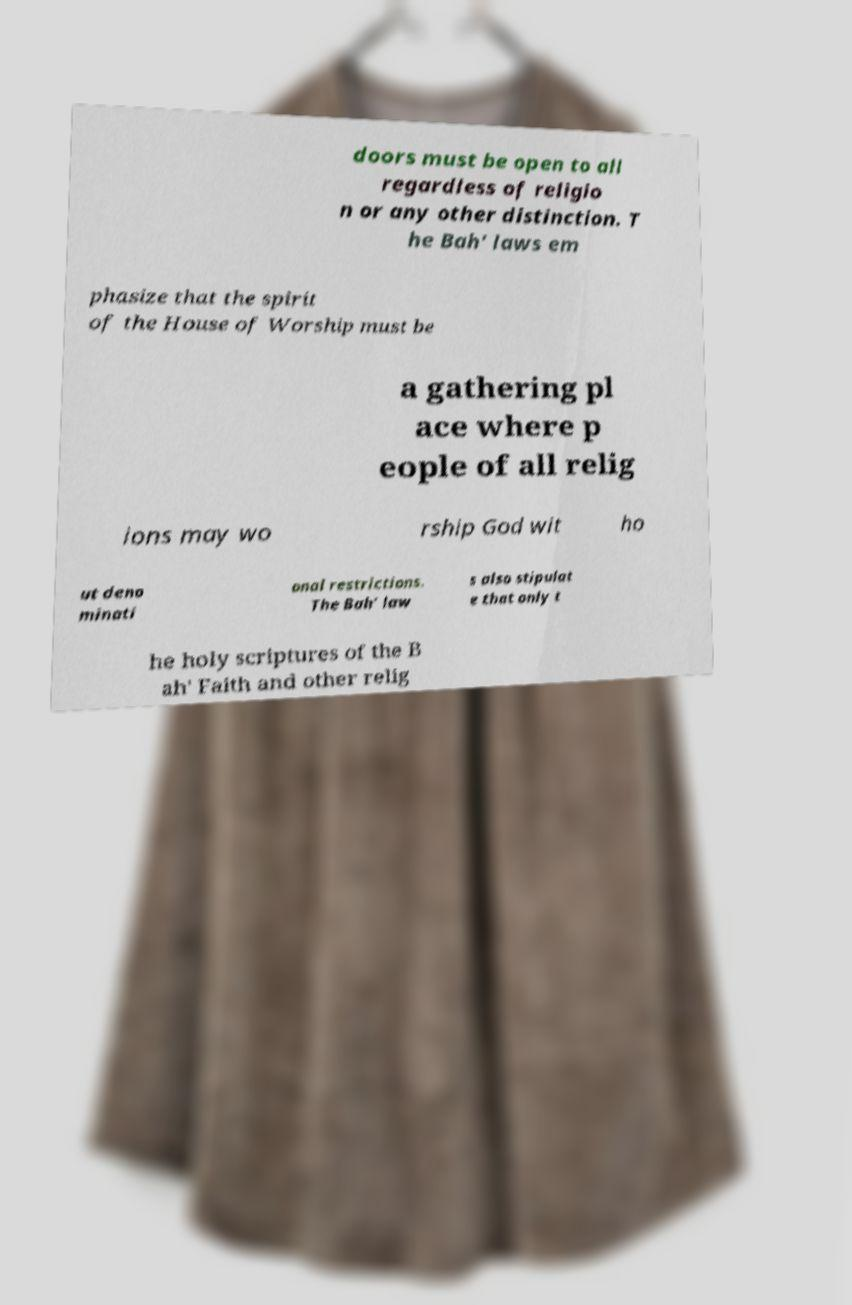Please read and relay the text visible in this image. What does it say? doors must be open to all regardless of religio n or any other distinction. T he Bah' laws em phasize that the spirit of the House of Worship must be a gathering pl ace where p eople of all relig ions may wo rship God wit ho ut deno minati onal restrictions. The Bah' law s also stipulat e that only t he holy scriptures of the B ah' Faith and other relig 